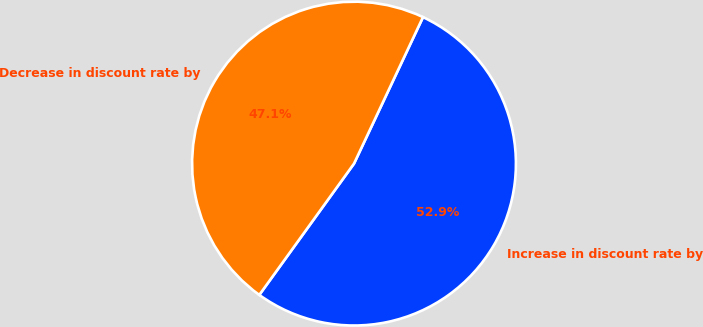Convert chart to OTSL. <chart><loc_0><loc_0><loc_500><loc_500><pie_chart><fcel>Increase in discount rate by<fcel>Decrease in discount rate by<nl><fcel>52.94%<fcel>47.06%<nl></chart> 